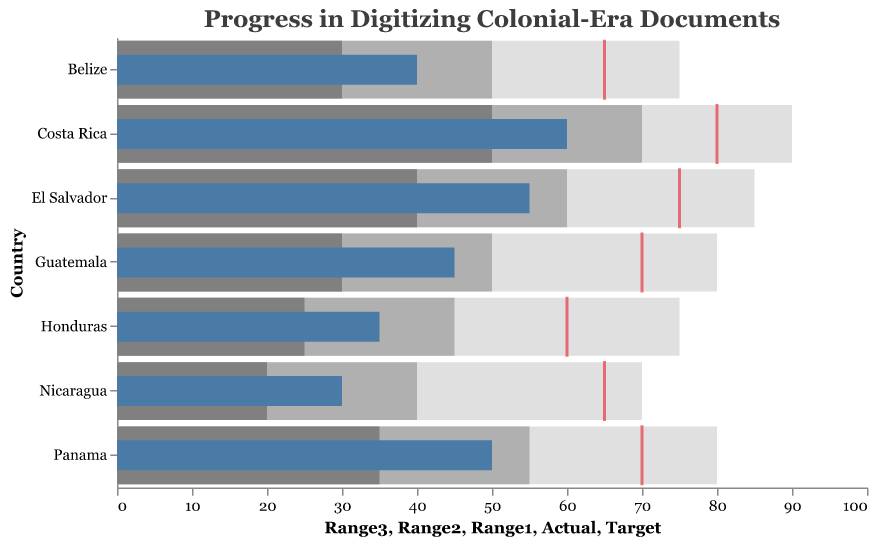What is the title of the Bullet Chart? The title is found at the top of the chart and typically describes the main purpose or content of the visualization. In this case, it provides a summary of the chart’s focus.
Answer: Progress in Digitizing Colonial-Era Documents What is the target digitization percentage for Belize? The target digitization percentage for Belize is indicated by the red tick mark aligned with the x-axis for the corresponding row of Belize.
Answer: 65 Which country has achieved the highest actual digitization percentage? By comparing the length of the blue bars across all countries, we can see which bar extends the farthest to the right.
Answer: Costa Rica What is the range of good, satisfactory, and excellent progress for Nicaragua? The ranges for good, satisfactory, and excellent progress are indicated by the lighter to darker grey bars in the background pertaining to Nicaragua's row.
Answer: Good: 20-40, Satisfactory: 40-70, Excellent: 70+ How far is Guatemala from achieving its target digitization percentage? Subtract Guatemala's actual digitization percentage (45) from its target percentage (70).
Answer: 25 Which countries have achieved at least 50% digitization? Find countries where the blue bar (actual digitization percentage) meets or exceeds 50 on the x-axis.
Answer: El Salvador, Costa Rica, Panama What is the average actual digitization percentage across all countries? Sum the actual digitization percentages for all countries and divide by the number of countries.
(45 + 35 + 55 + 30 + 60 + 50 + 40) / 7 = 315 / 7 = 45
Answer: 45 Which country is closest to its target digitization percentage? Calculate the difference between the actual and target percentages for each country and find the smallest difference.
Belize: 25, Guatemala: 25, Honduras: 25, El Salvador: 20, Nicaragua: 35, Costa Rica: 20, Panama: 20
Answer: El Salvador, Costa Rica, Panama How many countries have an actual digitization percentage within the satisfactory range (mid grey bar)? Count the countries where the blue bar (actual percentage) falls within the mid grey bar range.
Answer: 6 